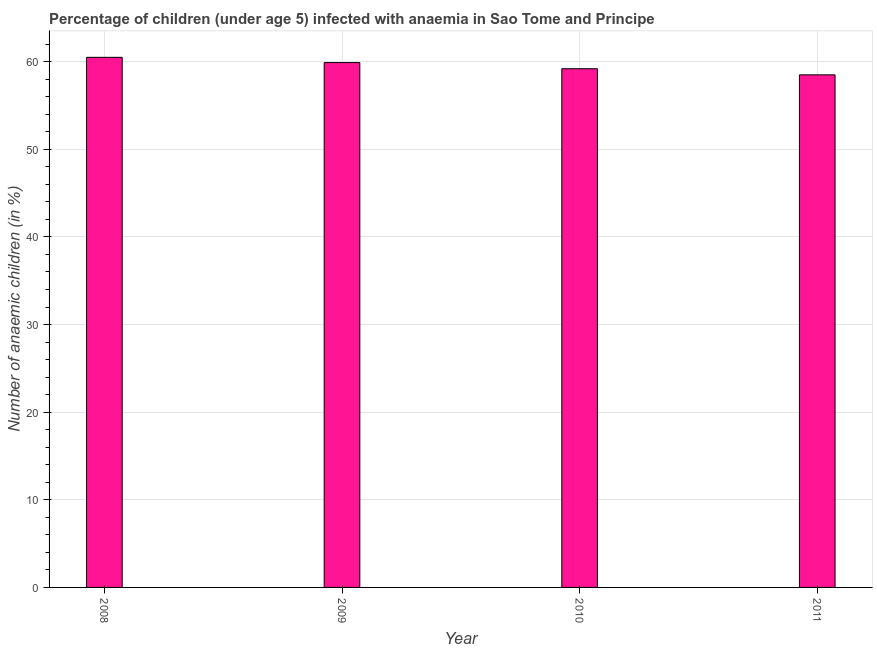What is the title of the graph?
Make the answer very short. Percentage of children (under age 5) infected with anaemia in Sao Tome and Principe. What is the label or title of the Y-axis?
Provide a succinct answer. Number of anaemic children (in %). What is the number of anaemic children in 2008?
Offer a very short reply. 60.5. Across all years, what is the maximum number of anaemic children?
Keep it short and to the point. 60.5. Across all years, what is the minimum number of anaemic children?
Give a very brief answer. 58.5. In which year was the number of anaemic children maximum?
Make the answer very short. 2008. In which year was the number of anaemic children minimum?
Make the answer very short. 2011. What is the sum of the number of anaemic children?
Offer a terse response. 238.1. What is the difference between the number of anaemic children in 2008 and 2010?
Provide a succinct answer. 1.3. What is the average number of anaemic children per year?
Give a very brief answer. 59.52. What is the median number of anaemic children?
Give a very brief answer. 59.55. In how many years, is the number of anaemic children greater than 18 %?
Make the answer very short. 4. Do a majority of the years between 2009 and 2011 (inclusive) have number of anaemic children greater than 28 %?
Your answer should be very brief. Yes. What is the ratio of the number of anaemic children in 2008 to that in 2009?
Give a very brief answer. 1.01. Is the difference between the number of anaemic children in 2009 and 2010 greater than the difference between any two years?
Make the answer very short. No. Is the sum of the number of anaemic children in 2010 and 2011 greater than the maximum number of anaemic children across all years?
Give a very brief answer. Yes. In how many years, is the number of anaemic children greater than the average number of anaemic children taken over all years?
Ensure brevity in your answer.  2. How many bars are there?
Offer a terse response. 4. Are all the bars in the graph horizontal?
Your response must be concise. No. Are the values on the major ticks of Y-axis written in scientific E-notation?
Your answer should be very brief. No. What is the Number of anaemic children (in %) in 2008?
Keep it short and to the point. 60.5. What is the Number of anaemic children (in %) of 2009?
Ensure brevity in your answer.  59.9. What is the Number of anaemic children (in %) in 2010?
Provide a short and direct response. 59.2. What is the Number of anaemic children (in %) of 2011?
Provide a succinct answer. 58.5. What is the difference between the Number of anaemic children (in %) in 2008 and 2009?
Provide a short and direct response. 0.6. What is the difference between the Number of anaemic children (in %) in 2008 and 2010?
Keep it short and to the point. 1.3. What is the ratio of the Number of anaemic children (in %) in 2008 to that in 2009?
Give a very brief answer. 1.01. What is the ratio of the Number of anaemic children (in %) in 2008 to that in 2011?
Provide a succinct answer. 1.03. What is the ratio of the Number of anaemic children (in %) in 2010 to that in 2011?
Offer a terse response. 1.01. 